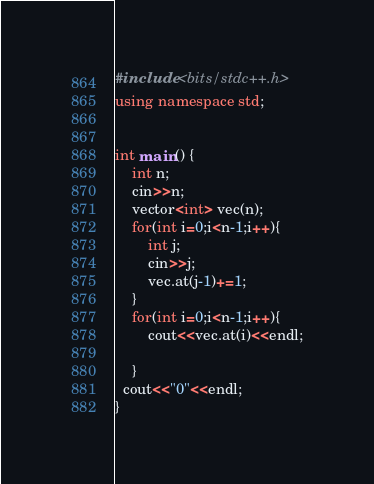<code> <loc_0><loc_0><loc_500><loc_500><_C++_>#include <bits/stdc++.h>
using namespace std;


int main() {
    int n;
    cin>>n;
    vector<int> vec(n);
    for(int i=0;i<n-1;i++){
        int j;
        cin>>j;
        vec.at(j-1)+=1;
    }
    for(int i=0;i<n-1;i++){
        cout<<vec.at(i)<<endl;
      	
    }
  cout<<"0"<<endl;
}</code> 